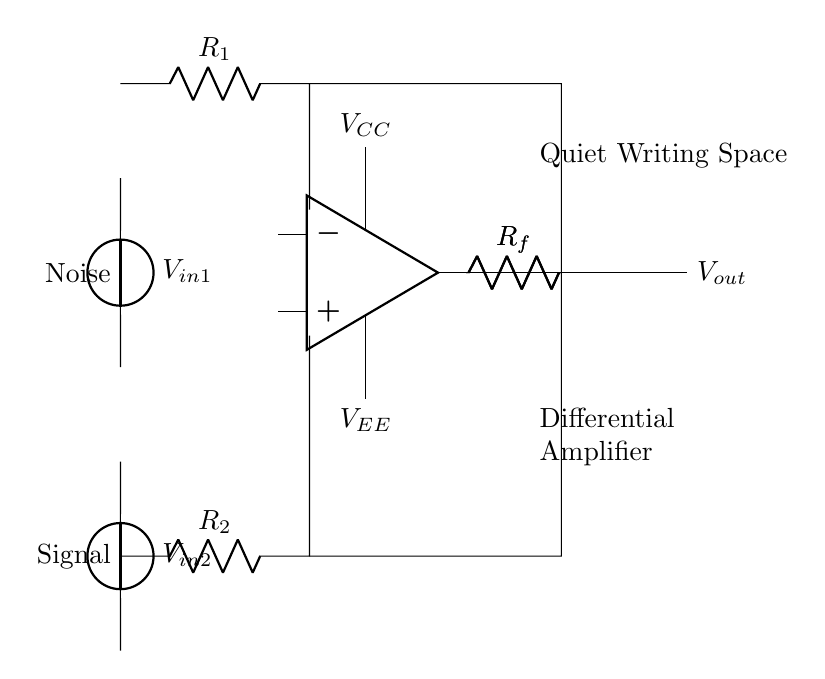What is the function of the operational amplifier in this circuit? The operational amplifier amplifies the difference in voltage between the two input signals, effectively enhancing the desired signal while minimizing noise.
Answer: Noise cancellation What are the values of the resistors labeled as R1 and R2? The values are not explicitly given in the circuit diagram; they represent the input resistances connected to the input voltages in the differential amplifier configuration.
Answer: Undefined How many input voltage sources are present in the circuit? There are two input voltage sources, labeled as V in1 and V in2, providing the signals to be amplified by the op-amp.
Answer: Two What is the role of the feedback resistors Rf? The feedback resistors Rf provide stability and set the gain of the differential amplifier, allowing for control over the output voltage based on the input differences.
Answer: Gain control What type of configuration does this circuit represent? This circuit is a differential amplifier configuration as it processes two input signals and amplifies the difference between them.
Answer: Differential amplifier What does the label "Quiet Writing Space" indicate in the circuit? The label indicates the intended application or environment where the amplifier is used, suggesting a focus on reducing noise for a better writing experience.
Answer: Application context 